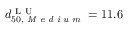<formula> <loc_0><loc_0><loc_500><loc_500>d _ { 5 0 , M e d i u m } ^ { L U } = 1 1 . 6</formula> 